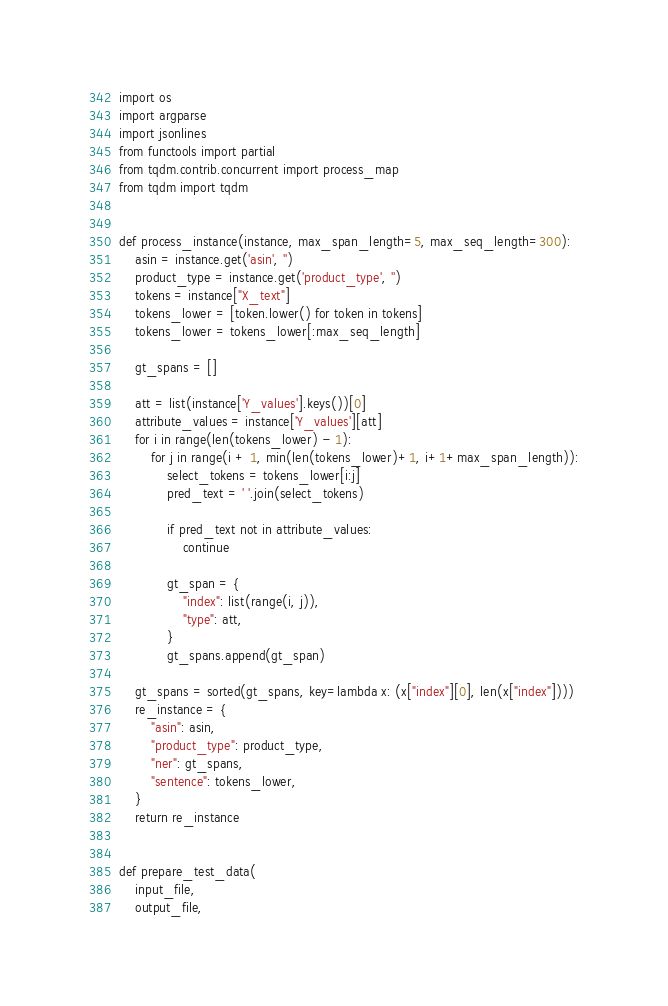<code> <loc_0><loc_0><loc_500><loc_500><_Python_>import os
import argparse
import jsonlines
from functools import partial
from tqdm.contrib.concurrent import process_map
from tqdm import tqdm


def process_instance(instance, max_span_length=5, max_seq_length=300):
    asin = instance.get('asin', '')
    product_type = instance.get('product_type', '')
    tokens = instance["X_text"]
    tokens_lower = [token.lower() for token in tokens]
    tokens_lower = tokens_lower[:max_seq_length]

    gt_spans = []

    att = list(instance['Y_values'].keys())[0]
    attribute_values = instance['Y_values'][att]
    for i in range(len(tokens_lower) - 1):
        for j in range(i + 1, min(len(tokens_lower)+1, i+1+max_span_length)):
            select_tokens = tokens_lower[i:j]
            pred_text = ' '.join(select_tokens)

            if pred_text not in attribute_values:
                continue

            gt_span = {
                "index": list(range(i, j)),
                "type": att,
            }
            gt_spans.append(gt_span)

    gt_spans = sorted(gt_spans, key=lambda x: (x["index"][0], len(x["index"])))
    re_instance = {
        "asin": asin,
        "product_type": product_type,
        "ner": gt_spans,
        "sentence": tokens_lower,
    }
    return re_instance


def prepare_test_data(
    input_file,
    output_file,</code> 